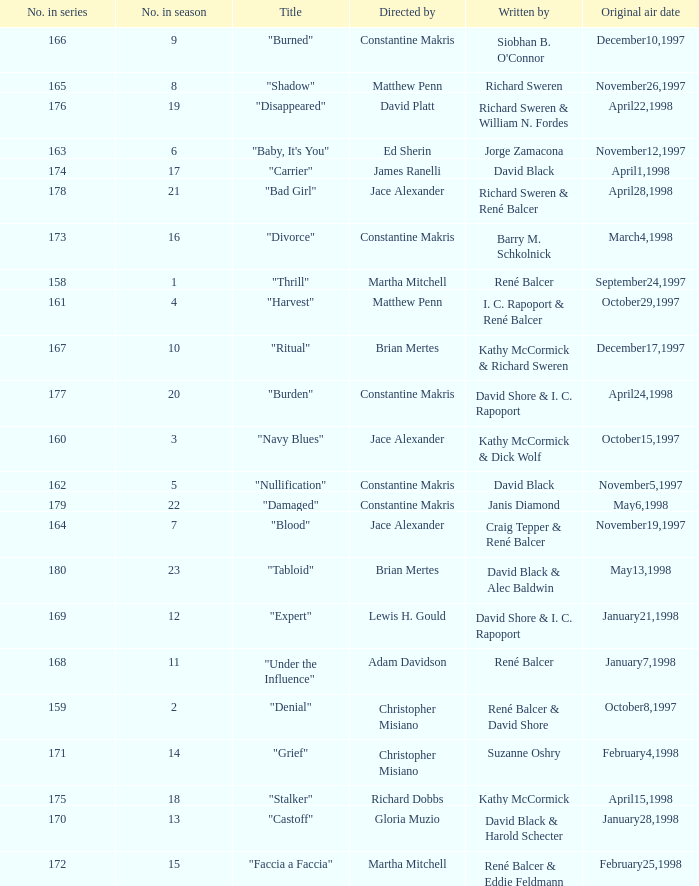The first episode in this season had what number in the series?  158.0. 